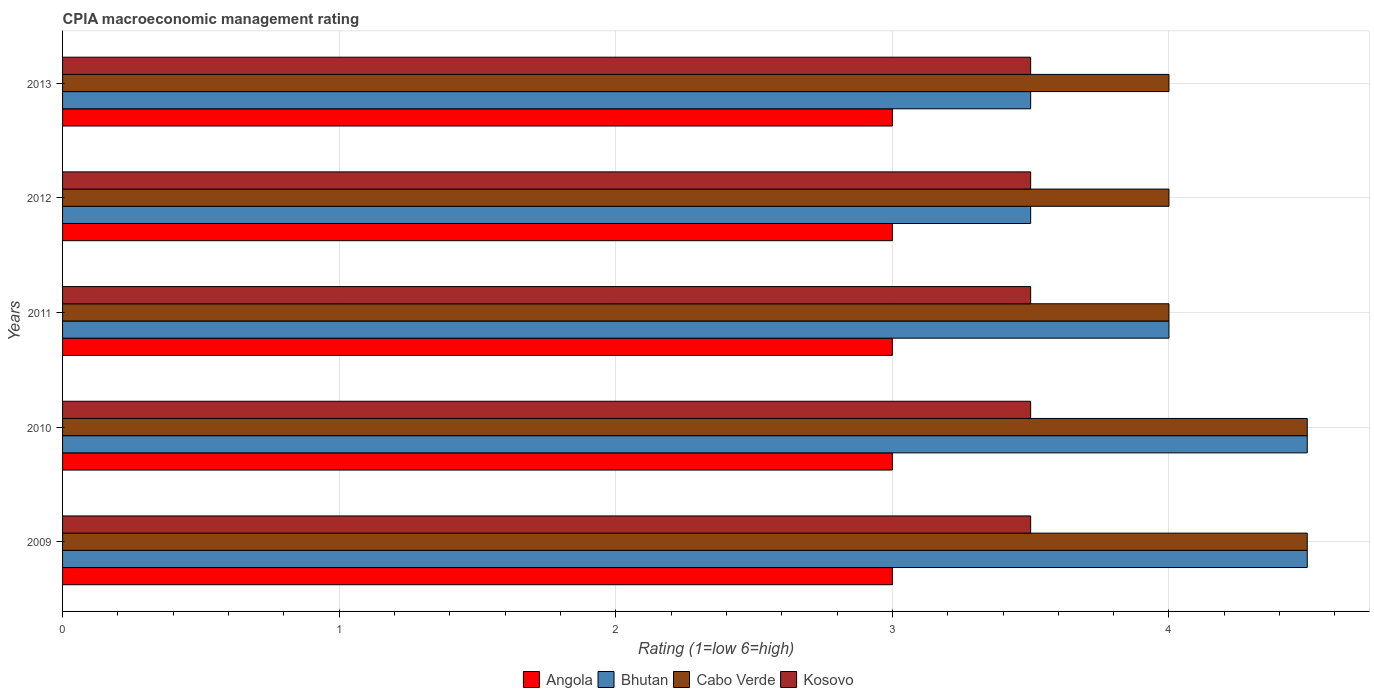How many different coloured bars are there?
Provide a short and direct response. 4. How many groups of bars are there?
Offer a terse response. 5. How many bars are there on the 4th tick from the bottom?
Keep it short and to the point. 4. In how many cases, is the number of bars for a given year not equal to the number of legend labels?
Provide a succinct answer. 0. In which year was the CPIA rating in Bhutan maximum?
Provide a short and direct response. 2009. What is the difference between the CPIA rating in Kosovo in 2009 and the CPIA rating in Angola in 2013?
Your response must be concise. 0.5. Is the CPIA rating in Cabo Verde in 2009 less than that in 2013?
Make the answer very short. No. Is the difference between the CPIA rating in Angola in 2009 and 2012 greater than the difference between the CPIA rating in Kosovo in 2009 and 2012?
Ensure brevity in your answer.  No. What is the difference between the highest and the second highest CPIA rating in Angola?
Your response must be concise. 0. In how many years, is the CPIA rating in Bhutan greater than the average CPIA rating in Bhutan taken over all years?
Your answer should be very brief. 2. Is the sum of the CPIA rating in Angola in 2009 and 2010 greater than the maximum CPIA rating in Kosovo across all years?
Ensure brevity in your answer.  Yes. What does the 3rd bar from the top in 2009 represents?
Your answer should be compact. Bhutan. What does the 2nd bar from the bottom in 2010 represents?
Keep it short and to the point. Bhutan. How many bars are there?
Offer a terse response. 20. How many years are there in the graph?
Make the answer very short. 5. What is the difference between two consecutive major ticks on the X-axis?
Your answer should be compact. 1. Does the graph contain grids?
Your answer should be very brief. Yes. How many legend labels are there?
Give a very brief answer. 4. What is the title of the graph?
Make the answer very short. CPIA macroeconomic management rating. Does "Uruguay" appear as one of the legend labels in the graph?
Offer a very short reply. No. What is the label or title of the X-axis?
Your answer should be very brief. Rating (1=low 6=high). What is the Rating (1=low 6=high) in Bhutan in 2009?
Ensure brevity in your answer.  4.5. What is the Rating (1=low 6=high) in Kosovo in 2009?
Keep it short and to the point. 3.5. What is the Rating (1=low 6=high) in Bhutan in 2010?
Make the answer very short. 4.5. What is the Rating (1=low 6=high) in Cabo Verde in 2010?
Make the answer very short. 4.5. What is the Rating (1=low 6=high) of Kosovo in 2010?
Offer a very short reply. 3.5. What is the Rating (1=low 6=high) in Kosovo in 2011?
Ensure brevity in your answer.  3.5. What is the Rating (1=low 6=high) of Bhutan in 2012?
Provide a short and direct response. 3.5. What is the Rating (1=low 6=high) of Cabo Verde in 2012?
Your answer should be very brief. 4. What is the Rating (1=low 6=high) in Kosovo in 2012?
Give a very brief answer. 3.5. What is the Rating (1=low 6=high) in Bhutan in 2013?
Ensure brevity in your answer.  3.5. What is the Rating (1=low 6=high) in Kosovo in 2013?
Your answer should be compact. 3.5. Across all years, what is the maximum Rating (1=low 6=high) of Bhutan?
Offer a very short reply. 4.5. Across all years, what is the maximum Rating (1=low 6=high) of Cabo Verde?
Your answer should be compact. 4.5. Across all years, what is the maximum Rating (1=low 6=high) of Kosovo?
Make the answer very short. 3.5. Across all years, what is the minimum Rating (1=low 6=high) in Angola?
Your response must be concise. 3. Across all years, what is the minimum Rating (1=low 6=high) of Bhutan?
Offer a very short reply. 3.5. Across all years, what is the minimum Rating (1=low 6=high) in Cabo Verde?
Give a very brief answer. 4. What is the difference between the Rating (1=low 6=high) in Angola in 2009 and that in 2010?
Keep it short and to the point. 0. What is the difference between the Rating (1=low 6=high) of Angola in 2009 and that in 2011?
Make the answer very short. 0. What is the difference between the Rating (1=low 6=high) of Kosovo in 2009 and that in 2011?
Provide a succinct answer. 0. What is the difference between the Rating (1=low 6=high) of Angola in 2009 and that in 2012?
Your answer should be compact. 0. What is the difference between the Rating (1=low 6=high) in Bhutan in 2009 and that in 2012?
Your answer should be compact. 1. What is the difference between the Rating (1=low 6=high) in Kosovo in 2009 and that in 2012?
Provide a short and direct response. 0. What is the difference between the Rating (1=low 6=high) of Angola in 2009 and that in 2013?
Your answer should be very brief. 0. What is the difference between the Rating (1=low 6=high) of Kosovo in 2009 and that in 2013?
Make the answer very short. 0. What is the difference between the Rating (1=low 6=high) of Angola in 2010 and that in 2011?
Provide a succinct answer. 0. What is the difference between the Rating (1=low 6=high) in Bhutan in 2010 and that in 2011?
Keep it short and to the point. 0.5. What is the difference between the Rating (1=low 6=high) of Kosovo in 2010 and that in 2011?
Your response must be concise. 0. What is the difference between the Rating (1=low 6=high) in Angola in 2010 and that in 2012?
Your response must be concise. 0. What is the difference between the Rating (1=low 6=high) in Cabo Verde in 2010 and that in 2013?
Make the answer very short. 0.5. What is the difference between the Rating (1=low 6=high) in Kosovo in 2010 and that in 2013?
Offer a very short reply. 0. What is the difference between the Rating (1=low 6=high) of Angola in 2011 and that in 2012?
Make the answer very short. 0. What is the difference between the Rating (1=low 6=high) of Cabo Verde in 2011 and that in 2012?
Give a very brief answer. 0. What is the difference between the Rating (1=low 6=high) of Kosovo in 2011 and that in 2012?
Give a very brief answer. 0. What is the difference between the Rating (1=low 6=high) in Bhutan in 2011 and that in 2013?
Offer a terse response. 0.5. What is the difference between the Rating (1=low 6=high) of Kosovo in 2011 and that in 2013?
Give a very brief answer. 0. What is the difference between the Rating (1=low 6=high) in Angola in 2012 and that in 2013?
Offer a terse response. 0. What is the difference between the Rating (1=low 6=high) of Angola in 2009 and the Rating (1=low 6=high) of Cabo Verde in 2010?
Provide a succinct answer. -1.5. What is the difference between the Rating (1=low 6=high) of Bhutan in 2009 and the Rating (1=low 6=high) of Kosovo in 2010?
Offer a terse response. 1. What is the difference between the Rating (1=low 6=high) of Cabo Verde in 2009 and the Rating (1=low 6=high) of Kosovo in 2010?
Ensure brevity in your answer.  1. What is the difference between the Rating (1=low 6=high) of Angola in 2009 and the Rating (1=low 6=high) of Bhutan in 2011?
Keep it short and to the point. -1. What is the difference between the Rating (1=low 6=high) in Angola in 2009 and the Rating (1=low 6=high) in Cabo Verde in 2011?
Your answer should be very brief. -1. What is the difference between the Rating (1=low 6=high) in Angola in 2009 and the Rating (1=low 6=high) in Kosovo in 2011?
Your answer should be compact. -0.5. What is the difference between the Rating (1=low 6=high) in Angola in 2009 and the Rating (1=low 6=high) in Bhutan in 2012?
Offer a terse response. -0.5. What is the difference between the Rating (1=low 6=high) of Angola in 2009 and the Rating (1=low 6=high) of Kosovo in 2012?
Offer a terse response. -0.5. What is the difference between the Rating (1=low 6=high) of Bhutan in 2009 and the Rating (1=low 6=high) of Cabo Verde in 2012?
Keep it short and to the point. 0.5. What is the difference between the Rating (1=low 6=high) in Angola in 2009 and the Rating (1=low 6=high) in Bhutan in 2013?
Offer a very short reply. -0.5. What is the difference between the Rating (1=low 6=high) in Angola in 2009 and the Rating (1=low 6=high) in Kosovo in 2013?
Offer a very short reply. -0.5. What is the difference between the Rating (1=low 6=high) in Bhutan in 2009 and the Rating (1=low 6=high) in Cabo Verde in 2013?
Your answer should be compact. 0.5. What is the difference between the Rating (1=low 6=high) in Bhutan in 2009 and the Rating (1=low 6=high) in Kosovo in 2013?
Provide a short and direct response. 1. What is the difference between the Rating (1=low 6=high) of Angola in 2010 and the Rating (1=low 6=high) of Bhutan in 2011?
Give a very brief answer. -1. What is the difference between the Rating (1=low 6=high) in Angola in 2010 and the Rating (1=low 6=high) in Cabo Verde in 2011?
Your answer should be very brief. -1. What is the difference between the Rating (1=low 6=high) of Angola in 2010 and the Rating (1=low 6=high) of Kosovo in 2011?
Your response must be concise. -0.5. What is the difference between the Rating (1=low 6=high) of Bhutan in 2010 and the Rating (1=low 6=high) of Kosovo in 2011?
Your response must be concise. 1. What is the difference between the Rating (1=low 6=high) in Angola in 2010 and the Rating (1=low 6=high) in Bhutan in 2012?
Your answer should be compact. -0.5. What is the difference between the Rating (1=low 6=high) of Angola in 2010 and the Rating (1=low 6=high) of Cabo Verde in 2012?
Keep it short and to the point. -1. What is the difference between the Rating (1=low 6=high) in Angola in 2010 and the Rating (1=low 6=high) in Kosovo in 2012?
Provide a succinct answer. -0.5. What is the difference between the Rating (1=low 6=high) of Bhutan in 2010 and the Rating (1=low 6=high) of Cabo Verde in 2012?
Ensure brevity in your answer.  0.5. What is the difference between the Rating (1=low 6=high) in Angola in 2010 and the Rating (1=low 6=high) in Bhutan in 2013?
Offer a terse response. -0.5. What is the difference between the Rating (1=low 6=high) in Cabo Verde in 2010 and the Rating (1=low 6=high) in Kosovo in 2013?
Ensure brevity in your answer.  1. What is the difference between the Rating (1=low 6=high) of Angola in 2011 and the Rating (1=low 6=high) of Bhutan in 2012?
Offer a very short reply. -0.5. What is the difference between the Rating (1=low 6=high) in Angola in 2011 and the Rating (1=low 6=high) in Kosovo in 2012?
Your answer should be compact. -0.5. What is the difference between the Rating (1=low 6=high) of Bhutan in 2011 and the Rating (1=low 6=high) of Cabo Verde in 2012?
Offer a terse response. 0. What is the difference between the Rating (1=low 6=high) of Bhutan in 2011 and the Rating (1=low 6=high) of Kosovo in 2012?
Your response must be concise. 0.5. What is the difference between the Rating (1=low 6=high) of Bhutan in 2011 and the Rating (1=low 6=high) of Cabo Verde in 2013?
Your answer should be very brief. 0. What is the difference between the Rating (1=low 6=high) in Bhutan in 2011 and the Rating (1=low 6=high) in Kosovo in 2013?
Your response must be concise. 0.5. What is the difference between the Rating (1=low 6=high) in Cabo Verde in 2011 and the Rating (1=low 6=high) in Kosovo in 2013?
Provide a short and direct response. 0.5. What is the difference between the Rating (1=low 6=high) of Angola in 2012 and the Rating (1=low 6=high) of Bhutan in 2013?
Keep it short and to the point. -0.5. What is the average Rating (1=low 6=high) of Angola per year?
Your answer should be very brief. 3. What is the average Rating (1=low 6=high) in Bhutan per year?
Provide a succinct answer. 4. What is the average Rating (1=low 6=high) in Cabo Verde per year?
Your response must be concise. 4.2. What is the average Rating (1=low 6=high) in Kosovo per year?
Offer a terse response. 3.5. In the year 2009, what is the difference between the Rating (1=low 6=high) of Angola and Rating (1=low 6=high) of Kosovo?
Ensure brevity in your answer.  -0.5. In the year 2009, what is the difference between the Rating (1=low 6=high) of Bhutan and Rating (1=low 6=high) of Kosovo?
Offer a terse response. 1. In the year 2009, what is the difference between the Rating (1=low 6=high) of Cabo Verde and Rating (1=low 6=high) of Kosovo?
Make the answer very short. 1. In the year 2010, what is the difference between the Rating (1=low 6=high) in Angola and Rating (1=low 6=high) in Cabo Verde?
Your response must be concise. -1.5. In the year 2010, what is the difference between the Rating (1=low 6=high) of Angola and Rating (1=low 6=high) of Kosovo?
Offer a terse response. -0.5. In the year 2010, what is the difference between the Rating (1=low 6=high) in Bhutan and Rating (1=low 6=high) in Cabo Verde?
Make the answer very short. 0. In the year 2010, what is the difference between the Rating (1=low 6=high) in Bhutan and Rating (1=low 6=high) in Kosovo?
Make the answer very short. 1. In the year 2011, what is the difference between the Rating (1=low 6=high) in Angola and Rating (1=low 6=high) in Cabo Verde?
Offer a very short reply. -1. In the year 2011, what is the difference between the Rating (1=low 6=high) of Bhutan and Rating (1=low 6=high) of Cabo Verde?
Keep it short and to the point. 0. In the year 2011, what is the difference between the Rating (1=low 6=high) in Bhutan and Rating (1=low 6=high) in Kosovo?
Offer a very short reply. 0.5. In the year 2012, what is the difference between the Rating (1=low 6=high) of Angola and Rating (1=low 6=high) of Bhutan?
Ensure brevity in your answer.  -0.5. In the year 2012, what is the difference between the Rating (1=low 6=high) of Angola and Rating (1=low 6=high) of Cabo Verde?
Ensure brevity in your answer.  -1. In the year 2012, what is the difference between the Rating (1=low 6=high) in Angola and Rating (1=low 6=high) in Kosovo?
Your response must be concise. -0.5. In the year 2012, what is the difference between the Rating (1=low 6=high) in Bhutan and Rating (1=low 6=high) in Cabo Verde?
Keep it short and to the point. -0.5. In the year 2012, what is the difference between the Rating (1=low 6=high) of Bhutan and Rating (1=low 6=high) of Kosovo?
Provide a short and direct response. 0. In the year 2013, what is the difference between the Rating (1=low 6=high) of Angola and Rating (1=low 6=high) of Cabo Verde?
Provide a short and direct response. -1. In the year 2013, what is the difference between the Rating (1=low 6=high) in Bhutan and Rating (1=low 6=high) in Cabo Verde?
Your answer should be very brief. -0.5. In the year 2013, what is the difference between the Rating (1=low 6=high) of Bhutan and Rating (1=low 6=high) of Kosovo?
Your answer should be very brief. 0. What is the ratio of the Rating (1=low 6=high) in Bhutan in 2009 to that in 2010?
Your answer should be very brief. 1. What is the ratio of the Rating (1=low 6=high) of Cabo Verde in 2009 to that in 2010?
Your answer should be compact. 1. What is the ratio of the Rating (1=low 6=high) in Angola in 2009 to that in 2011?
Give a very brief answer. 1. What is the ratio of the Rating (1=low 6=high) in Cabo Verde in 2009 to that in 2011?
Offer a terse response. 1.12. What is the ratio of the Rating (1=low 6=high) of Kosovo in 2009 to that in 2011?
Offer a very short reply. 1. What is the ratio of the Rating (1=low 6=high) of Angola in 2009 to that in 2012?
Provide a short and direct response. 1. What is the ratio of the Rating (1=low 6=high) in Cabo Verde in 2009 to that in 2012?
Offer a terse response. 1.12. What is the ratio of the Rating (1=low 6=high) of Bhutan in 2009 to that in 2013?
Provide a short and direct response. 1.29. What is the ratio of the Rating (1=low 6=high) in Cabo Verde in 2009 to that in 2013?
Offer a very short reply. 1.12. What is the ratio of the Rating (1=low 6=high) of Kosovo in 2009 to that in 2013?
Make the answer very short. 1. What is the ratio of the Rating (1=low 6=high) in Angola in 2010 to that in 2012?
Provide a short and direct response. 1. What is the ratio of the Rating (1=low 6=high) of Cabo Verde in 2010 to that in 2012?
Your answer should be very brief. 1.12. What is the ratio of the Rating (1=low 6=high) in Kosovo in 2010 to that in 2012?
Offer a terse response. 1. What is the ratio of the Rating (1=low 6=high) in Cabo Verde in 2010 to that in 2013?
Provide a succinct answer. 1.12. What is the ratio of the Rating (1=low 6=high) of Angola in 2011 to that in 2012?
Your answer should be compact. 1. What is the ratio of the Rating (1=low 6=high) in Bhutan in 2011 to that in 2012?
Give a very brief answer. 1.14. What is the ratio of the Rating (1=low 6=high) in Bhutan in 2011 to that in 2013?
Give a very brief answer. 1.14. What is the ratio of the Rating (1=low 6=high) in Cabo Verde in 2011 to that in 2013?
Your answer should be compact. 1. What is the ratio of the Rating (1=low 6=high) of Angola in 2012 to that in 2013?
Ensure brevity in your answer.  1. What is the ratio of the Rating (1=low 6=high) of Kosovo in 2012 to that in 2013?
Provide a short and direct response. 1. What is the difference between the highest and the second highest Rating (1=low 6=high) in Angola?
Provide a short and direct response. 0. What is the difference between the highest and the second highest Rating (1=low 6=high) in Bhutan?
Your answer should be compact. 0. What is the difference between the highest and the lowest Rating (1=low 6=high) of Bhutan?
Provide a succinct answer. 1. 